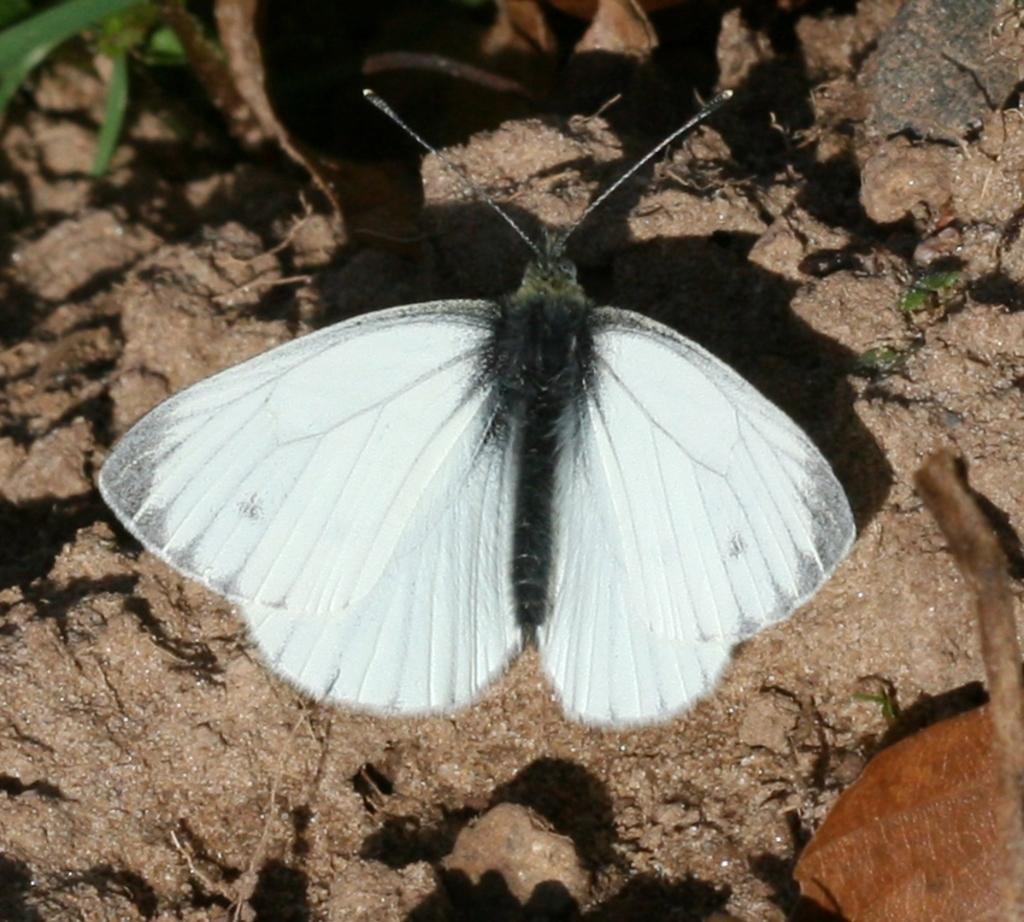Can you describe this image briefly? This is the picture of a fly which is in black and white color on the floor which has some sand and stones. 